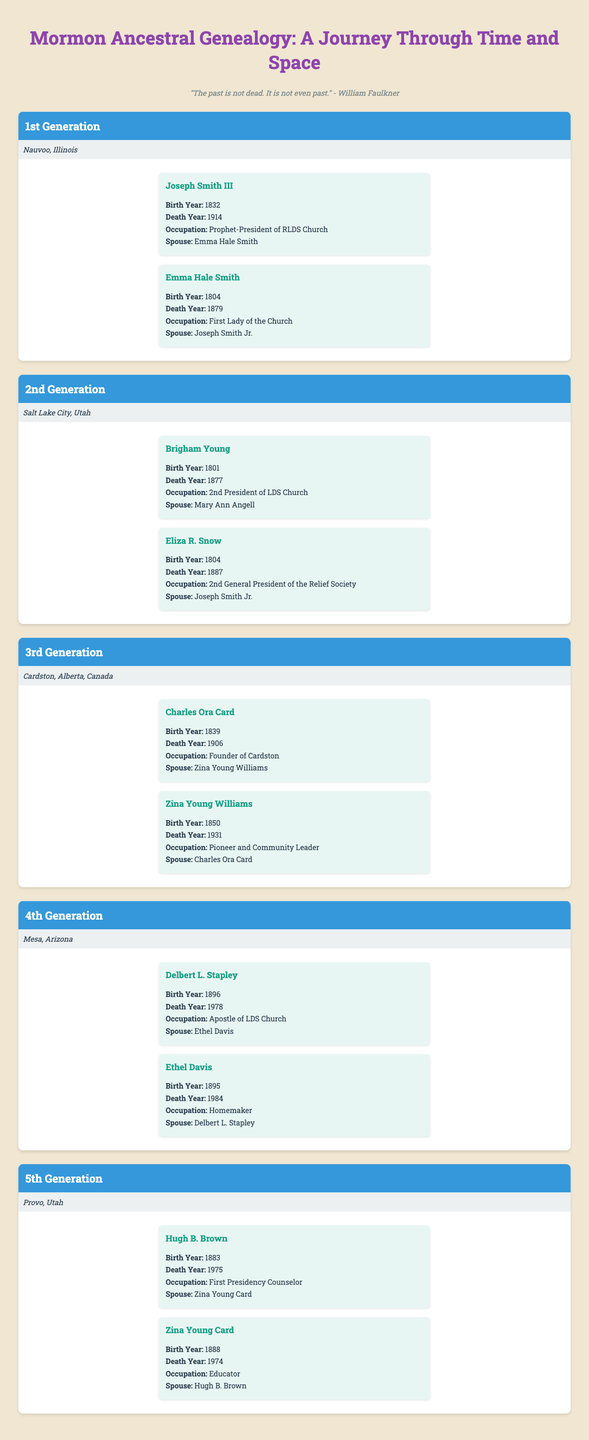What is the birth year of Emma Hale Smith? By looking at the "1st Generation" section in the table, Emma Hale Smith's birth year is listed as 1804.
Answer: 1804 Who are the ancestors from the 4th Generation? In the "4th Generation" section, the ancestors listed are Delbert L. Stapley and Ethel Davis.
Answer: Delbert L. Stapley and Ethel Davis What was Brigham Young's occupation? According to the "2nd Generation" section, Brigham Young is noted as the "2nd President of LDS Church."
Answer: 2nd President of LDS Church Which ancestor was born in 1839? In the "3rd Generation," Charles Ora Card has a birth year of 1839.
Answer: Charles Ora Card How many generations are represented in the table? The table shows five distinct generations: 1st to 5th Generation.
Answer: 5 generations What is the average birth year of the ancestors listed? The birth years are 1832 (Joseph Smith III), 1804 (Emma Hale Smith), 1801 (Brigham Young), 1804 (Eliza R. Snow), 1839 (Charles Ora Card), 1850 (Zina Young Williams), 1896 (Delbert L. Stapley), 1895 (Ethel Davis), 1883 (Hugh B. Brown), and 1888 (Zina Young Card). The average is calculated as follows: (1832 + 1804 + 1801 + 1804 + 1839 + 1850 + 1896 + 1895 + 1883 + 1888) / 10 = 1850.8.
Answer: 1850.8 Is Zina Young Cards's spouse listed in the table? Yes, Zina Young Card’s spouse, Hugh B. Brown, is listed in the table.
Answer: Yes Which ancestors have the same birth year? The ancestors Brigham Young and Eliza R. Snow both were born in 1804.
Answer: Brigham Young and Eliza R. Snow Who was the spouse of Charles Ora Card? The table states that Zina Young Williams is the spouse of Charles Ora Card in the "3rd Generation" section.
Answer: Zina Young Williams What is the death year of Hugh B. Brown? According to the "5th Generation," Hugh B. Brown's death year is 1975.
Answer: 1975 How many of the ancestors were homemakers? The table shows that Ethel Davis is noted as a homemaker in the "4th Generation." Therefore, there is one ancestor who was a homemaker.
Answer: 1 